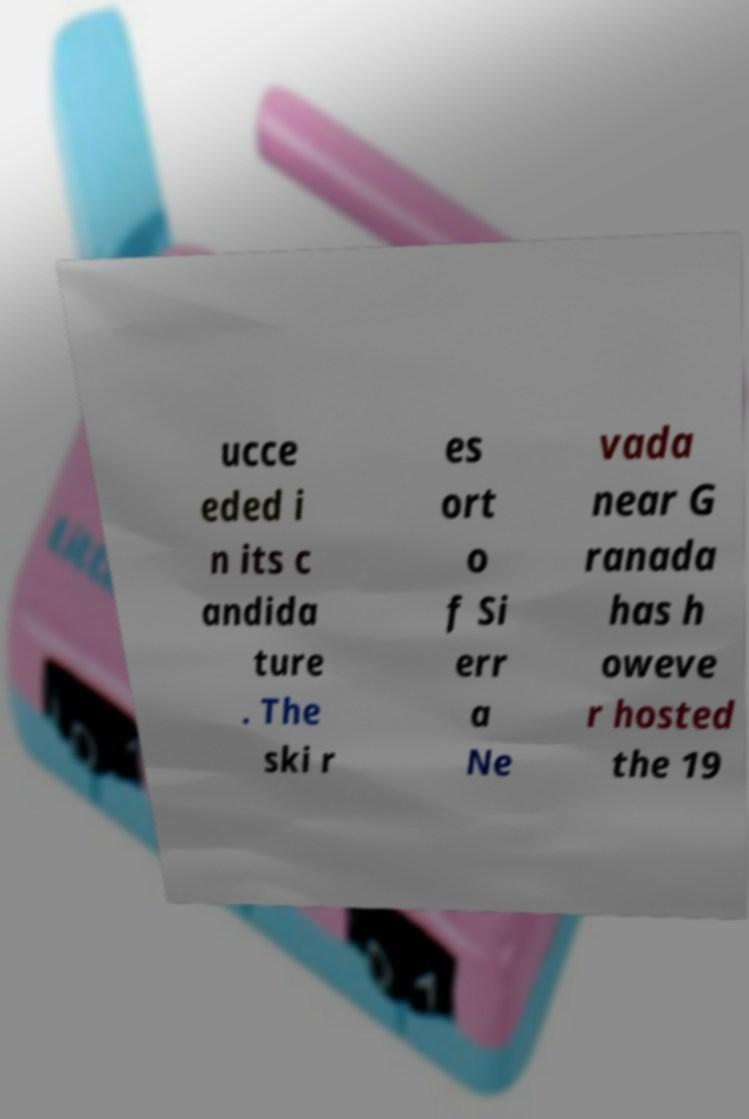What messages or text are displayed in this image? I need them in a readable, typed format. ucce eded i n its c andida ture . The ski r es ort o f Si err a Ne vada near G ranada has h oweve r hosted the 19 